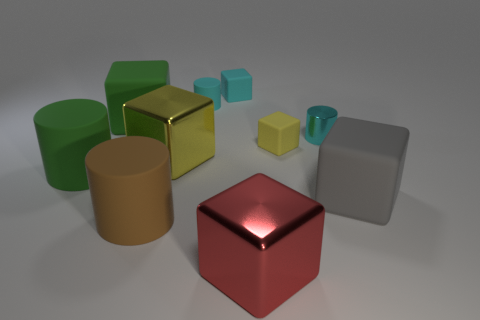Is the number of small cyan objects that are to the right of the tiny yellow matte thing greater than the number of tiny cyan metallic objects that are left of the tiny cyan shiny thing?
Keep it short and to the point. Yes. What number of other things are there of the same size as the red cube?
Give a very brief answer. 5. Does the matte cylinder that is on the right side of the brown thing have the same color as the shiny cylinder?
Your answer should be compact. Yes. Is the number of matte cylinders that are behind the big green cylinder greater than the number of big yellow matte blocks?
Provide a succinct answer. Yes. What is the shape of the small rubber object in front of the large rubber cube that is to the left of the big yellow block?
Your response must be concise. Cube. Is the number of brown cylinders greater than the number of big red metallic cylinders?
Your response must be concise. Yes. What number of large blocks are both in front of the small yellow block and on the left side of the small cyan shiny cylinder?
Your response must be concise. 2. There is a metal object to the left of the red object; how many large green rubber blocks are to the left of it?
Your answer should be compact. 1. What number of objects are tiny cyan cylinders that are on the right side of the tiny yellow matte thing or matte cubes that are on the right side of the large brown cylinder?
Provide a succinct answer. 4. There is a big yellow object that is the same shape as the big gray rubber object; what material is it?
Offer a terse response. Metal. 